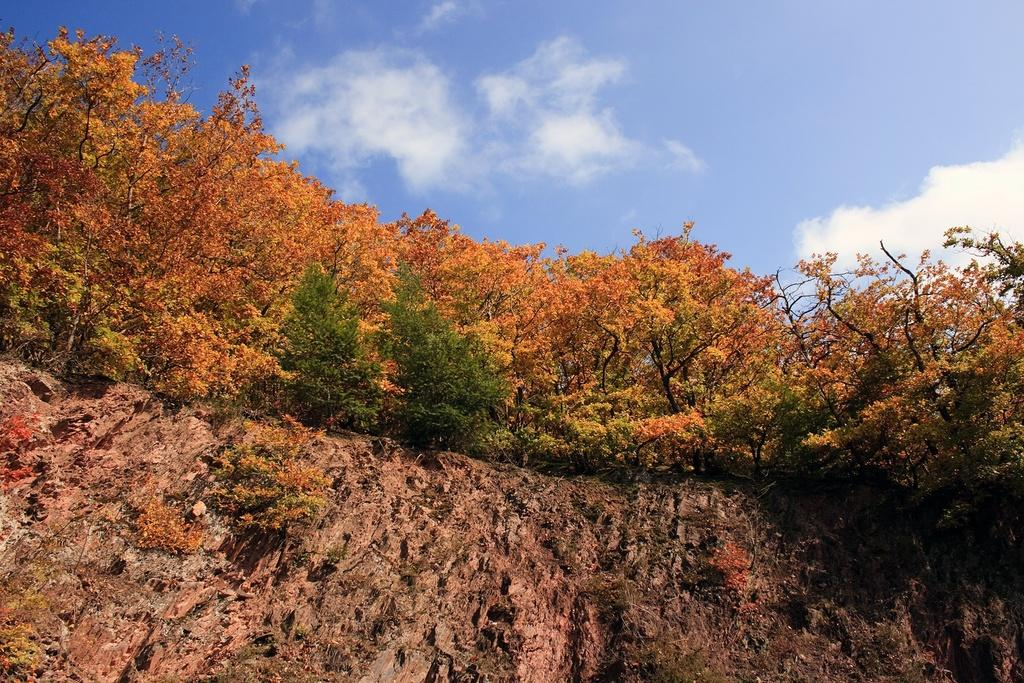What type of vegetation can be seen in the image? There are trees in the image. What part of the natural environment is visible in the image? The sky is visible in the image. What can be observed in the sky? Clouds are present in the sky. What type of geographical feature is visible in the image? There are hills in the image. What type of pump can be seen operating in the image? There is no pump present in the image. What type of creature is visible among the trees in the image? There are no creatures visible in the image; only trees, sky, clouds, and hills are present. 